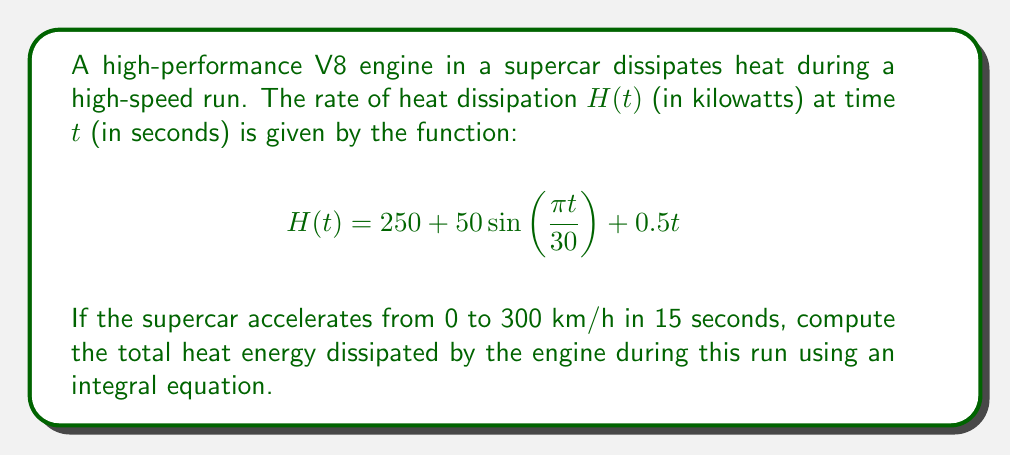Show me your answer to this math problem. To solve this problem, we need to follow these steps:

1) The total heat energy dissipated is the integral of the heat dissipation rate over time. We need to integrate $H(t)$ from $t=0$ to $t=15$.

2) Set up the integral equation:

   $$E = \int_0^{15} H(t) dt = \int_0^{15} (250 + 50\sin(\frac{\pi t}{30}) + 0.5t) dt$$

3) Break down the integral into three parts:

   $$E = \int_0^{15} 250 dt + \int_0^{15} 50\sin(\frac{\pi t}{30}) dt + \int_0^{15} 0.5t dt$$

4) Solve each part:
   
   Part 1: $\int_0^{15} 250 dt = 250t \Big|_0^{15} = 3750$

   Part 2: $\int_0^{15} 50\sin(\frac{\pi t}{30}) dt = -\frac{1500}{\pi} \cos(\frac{\pi t}{30}) \Big|_0^{15} = -\frac{1500}{\pi} [\cos(\frac{\pi}{2}) - 1] = \frac{1500}{\pi}$

   Part 3: $\int_0^{15} 0.5t dt = 0.25t^2 \Big|_0^{15} = 56.25$

5) Sum up all parts:

   $$E = 3750 + \frac{1500}{\pi} + 56.25 = 3806.25 + \frac{1500}{\pi}$$

6) Convert to kJ (as energy is typically measured in kJ):

   $$E = (3806.25 + \frac{1500}{\pi}) \text{ kW} \cdot 15 \text{ s} = 57093.75 + \frac{22500}{\pi} \text{ kJ}$$
Answer: $57093.75 + \frac{22500}{\pi}$ kJ 